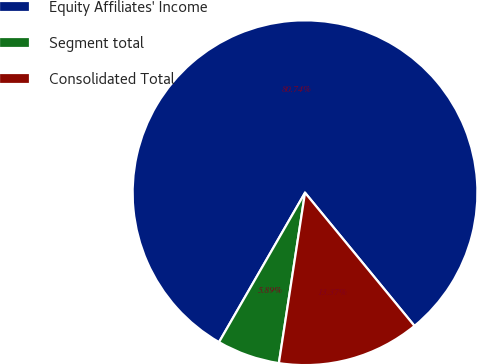Convert chart to OTSL. <chart><loc_0><loc_0><loc_500><loc_500><pie_chart><fcel>Equity Affiliates' Income<fcel>Segment total<fcel>Consolidated Total<nl><fcel>80.74%<fcel>5.89%<fcel>13.37%<nl></chart> 